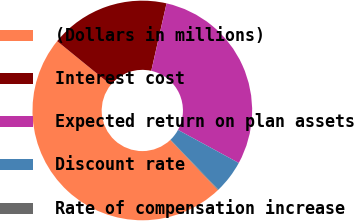Convert chart to OTSL. <chart><loc_0><loc_0><loc_500><loc_500><pie_chart><fcel>(Dollars in millions)<fcel>Interest cost<fcel>Expected return on plan assets<fcel>Discount rate<fcel>Rate of compensation increase<nl><fcel>47.96%<fcel>17.67%<fcel>29.39%<fcel>4.88%<fcel>0.1%<nl></chart> 